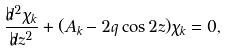Convert formula to latex. <formula><loc_0><loc_0><loc_500><loc_500>\frac { \flat d ^ { 2 } \chi _ { k } } { \flat d z ^ { 2 } } + ( A _ { k } - 2 q \cos 2 z ) \chi _ { k } = 0 ,</formula> 